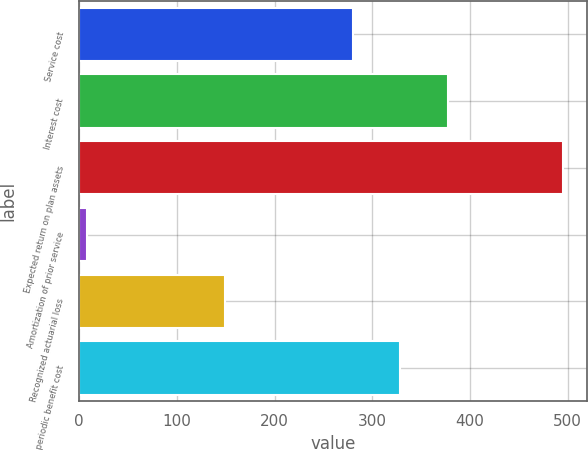<chart> <loc_0><loc_0><loc_500><loc_500><bar_chart><fcel>Service cost<fcel>Interest cost<fcel>Expected return on plan assets<fcel>Amortization of prior service<fcel>Recognized actuarial loss<fcel>Net periodic benefit cost<nl><fcel>280<fcel>377.3<fcel>494.8<fcel>8.3<fcel>149.6<fcel>328.65<nl></chart> 